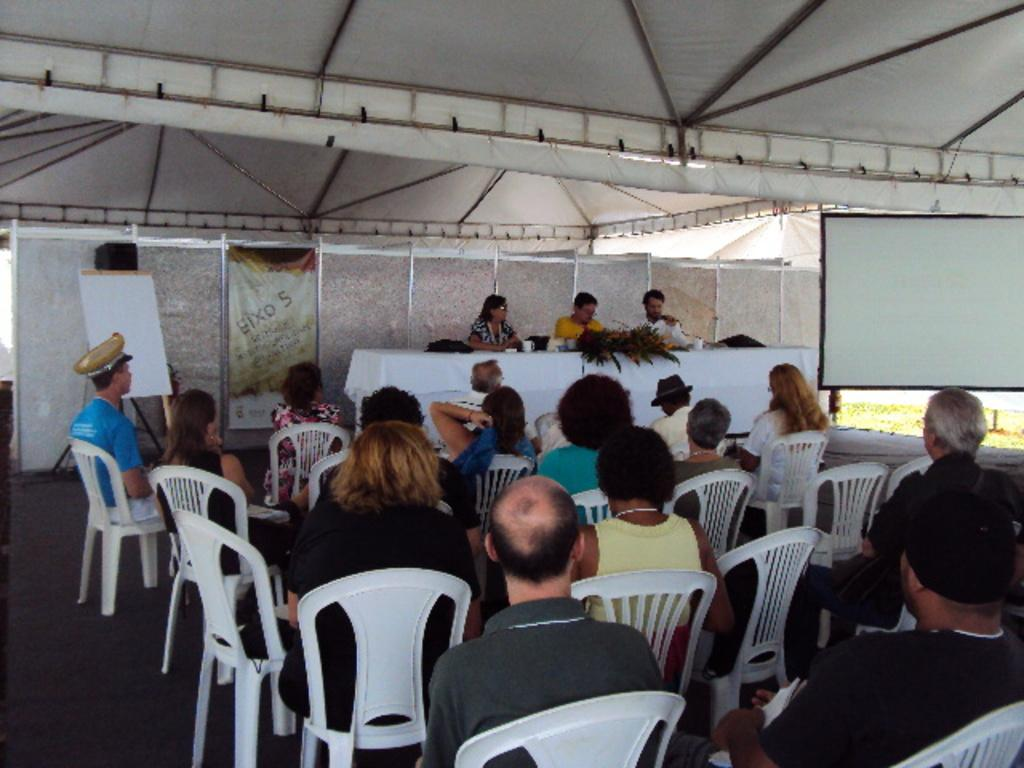What are the people in the image doing? The people in the image are sitting on chairs. Where are the people sitting in the image? The people are sitting on a stage in the image. What type of cub can be seen playing with pies on the edge of the stage in the image? There is no cub or pies present in the image; it only features people sitting on chairs on a stage. 